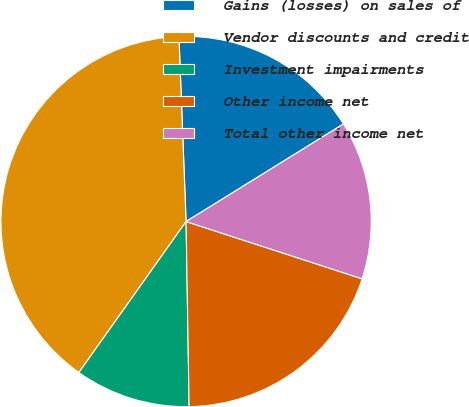<chart> <loc_0><loc_0><loc_500><loc_500><pie_chart><fcel>Gains (losses) on sales of<fcel>Vendor discounts and credit<fcel>Investment impairments<fcel>Other income net<fcel>Total other income net<nl><fcel>16.78%<fcel>39.56%<fcel>10.09%<fcel>19.73%<fcel>13.84%<nl></chart> 